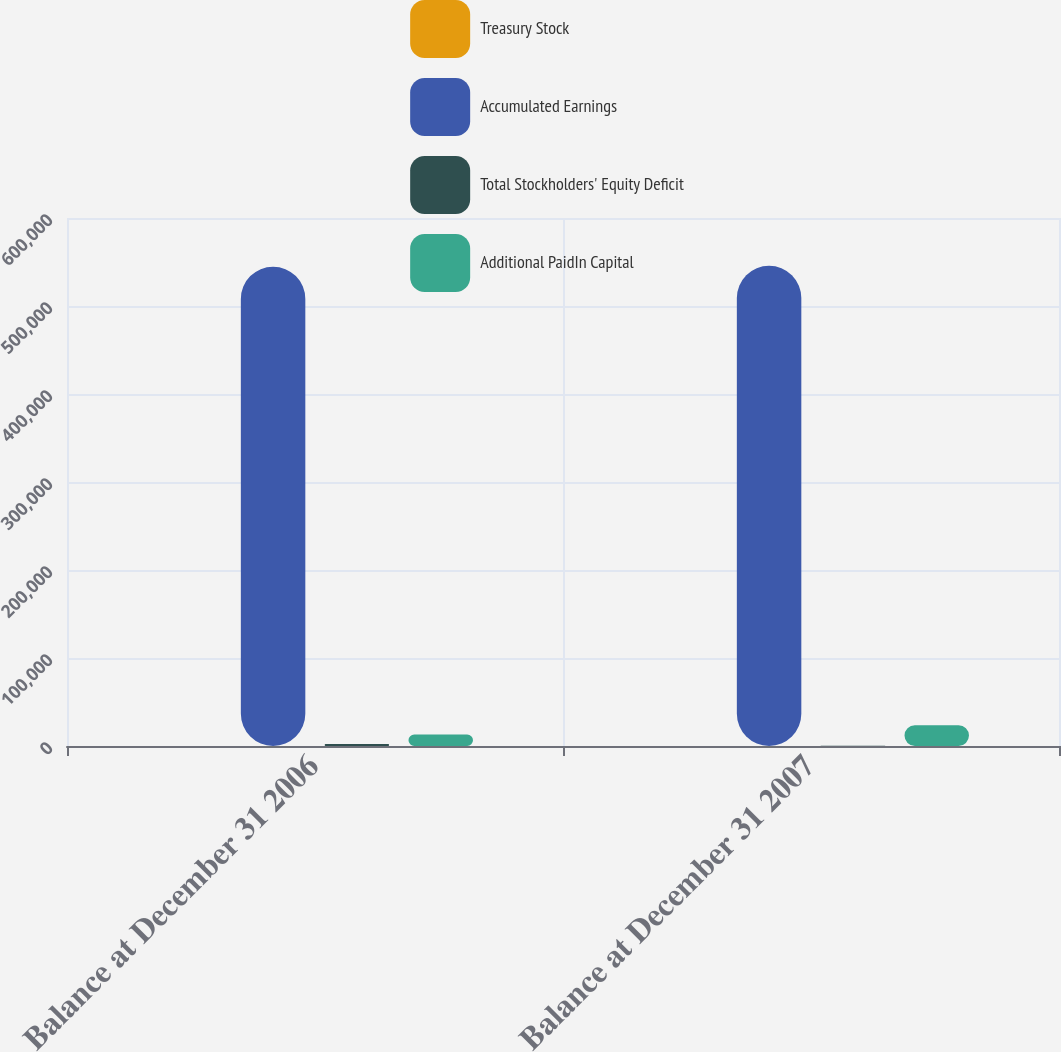Convert chart to OTSL. <chart><loc_0><loc_0><loc_500><loc_500><stacked_bar_chart><ecel><fcel>Balance at December 31 2006<fcel>Balance at December 31 2007<nl><fcel>Treasury Stock<fcel>78<fcel>78<nl><fcel>Accumulated Earnings<fcel>544686<fcel>545654<nl><fcel>Total Stockholders' Equity Deficit<fcel>2208<fcel>386<nl><fcel>Additional PaidIn Capital<fcel>13097<fcel>23641<nl></chart> 